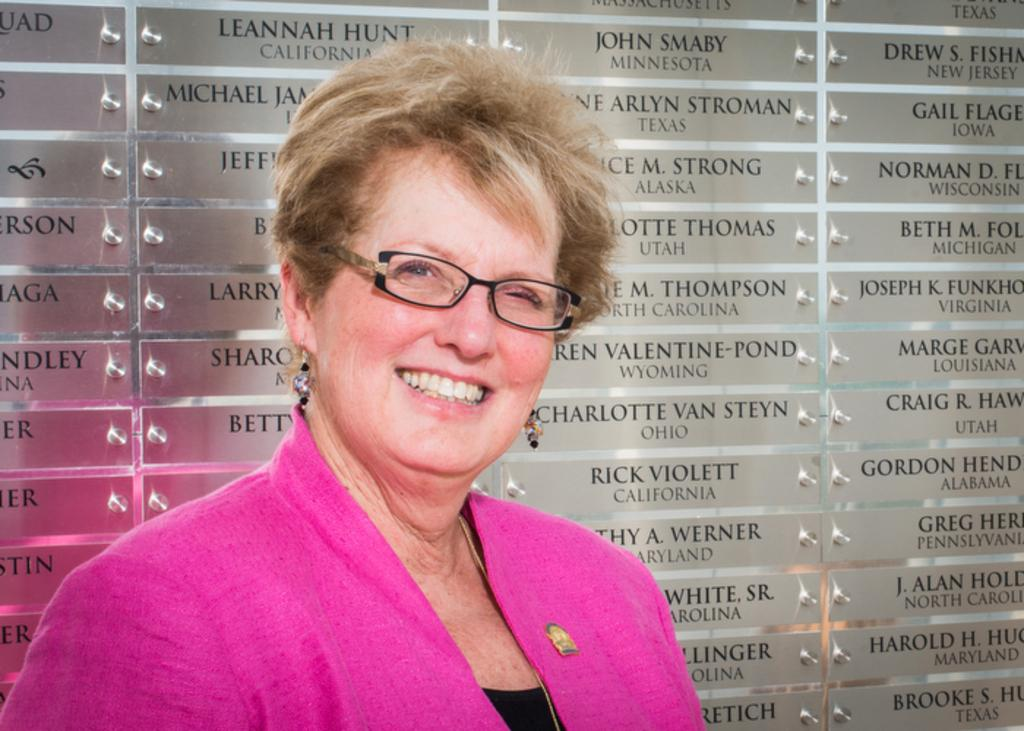Who is present in the image? There is a woman in the image. What is the woman doing in the image? The woman is smiling in the image. What is the woman wearing in the image? The woman is wearing a pink coat in the image. What can be seen in the background of the image? There is an honor board in the background of the image. What type of destruction is the woman causing in the image? There is no destruction present in the image; the woman is simply smiling and wearing a pink coat. What is the woman's opinion on trains in the image? There is no mention of trains or opinions in the image; it only shows a woman smiling and wearing a pink coat with an honor board in the background. 